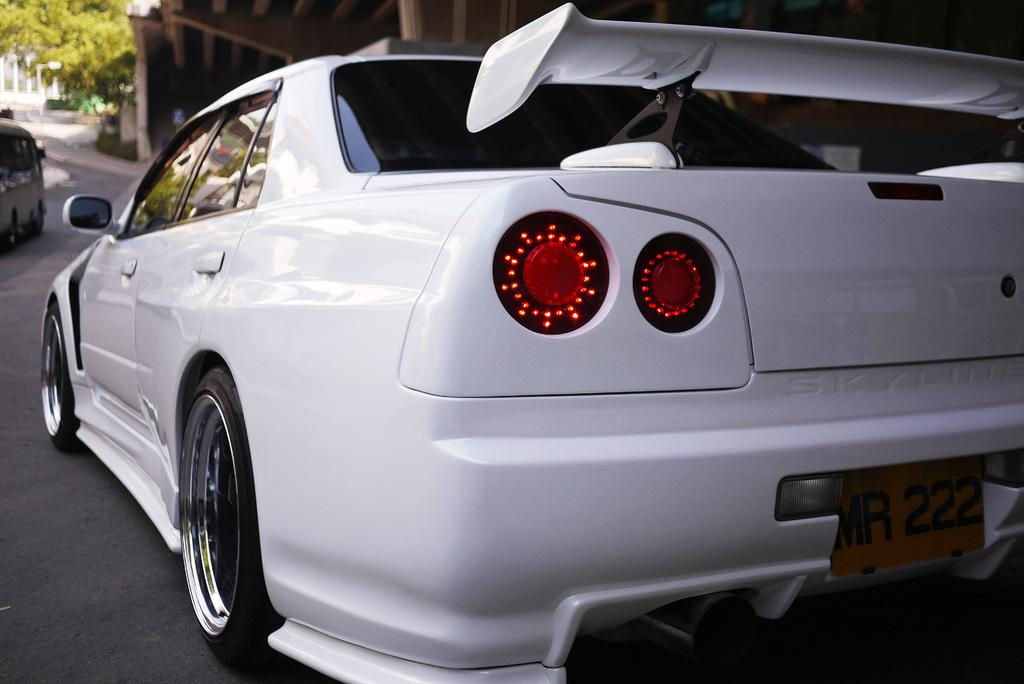What type of vehicle is on the right side of the image? There is a white color vehicle on the right side of the image. Where is the vehicle located? The vehicle is on a road. What can be seen in the background of the image? There are trees, a flyover, another vehicle, and a building in the background of the image. What type of science is being conducted in the image? There is no indication of any scientific activity in the image; it primarily features a vehicle on a road and background elements. 